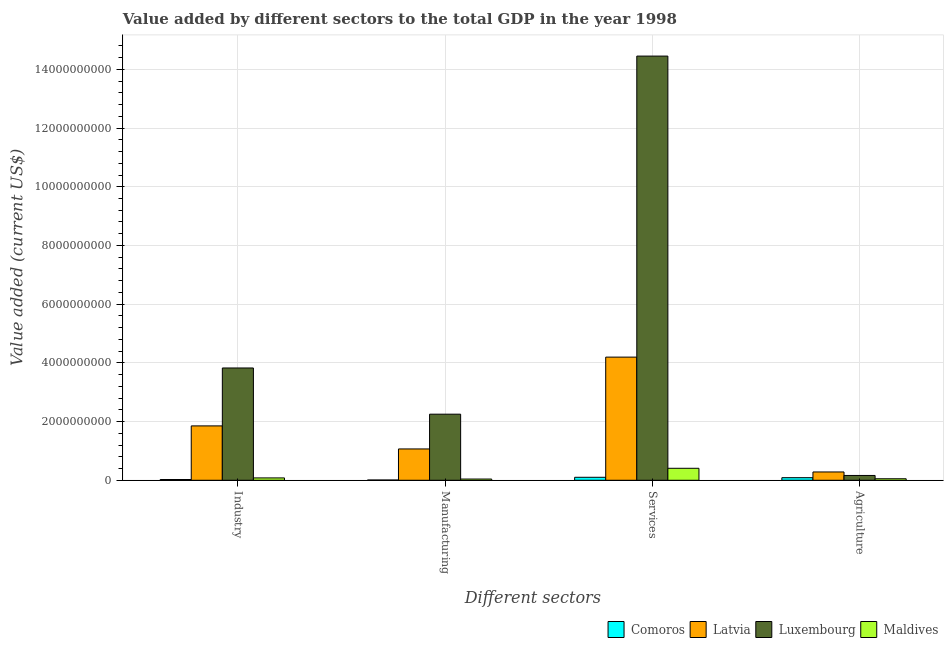Are the number of bars per tick equal to the number of legend labels?
Give a very brief answer. Yes. Are the number of bars on each tick of the X-axis equal?
Keep it short and to the point. Yes. How many bars are there on the 3rd tick from the left?
Provide a short and direct response. 4. What is the label of the 2nd group of bars from the left?
Your answer should be compact. Manufacturing. What is the value added by manufacturing sector in Comoros?
Provide a succinct answer. 8.97e+06. Across all countries, what is the maximum value added by industrial sector?
Your response must be concise. 3.83e+09. Across all countries, what is the minimum value added by services sector?
Provide a succinct answer. 1.02e+08. In which country was the value added by manufacturing sector maximum?
Ensure brevity in your answer.  Luxembourg. In which country was the value added by manufacturing sector minimum?
Make the answer very short. Comoros. What is the total value added by manufacturing sector in the graph?
Give a very brief answer. 3.37e+09. What is the difference between the value added by industrial sector in Latvia and that in Maldives?
Your answer should be very brief. 1.77e+09. What is the difference between the value added by manufacturing sector in Latvia and the value added by agricultural sector in Comoros?
Provide a succinct answer. 9.79e+08. What is the average value added by services sector per country?
Provide a short and direct response. 4.79e+09. What is the difference between the value added by manufacturing sector and value added by industrial sector in Comoros?
Your answer should be compact. -1.68e+07. What is the ratio of the value added by agricultural sector in Latvia to that in Luxembourg?
Keep it short and to the point. 1.73. Is the value added by manufacturing sector in Latvia less than that in Comoros?
Offer a terse response. No. What is the difference between the highest and the second highest value added by services sector?
Your answer should be compact. 1.03e+1. What is the difference between the highest and the lowest value added by industrial sector?
Your response must be concise. 3.80e+09. Is the sum of the value added by services sector in Latvia and Luxembourg greater than the maximum value added by manufacturing sector across all countries?
Provide a succinct answer. Yes. What does the 4th bar from the left in Services represents?
Keep it short and to the point. Maldives. What does the 3rd bar from the right in Manufacturing represents?
Provide a succinct answer. Latvia. How many countries are there in the graph?
Your answer should be compact. 4. Does the graph contain grids?
Offer a very short reply. Yes. Where does the legend appear in the graph?
Your response must be concise. Bottom right. How many legend labels are there?
Your response must be concise. 4. What is the title of the graph?
Offer a terse response. Value added by different sectors to the total GDP in the year 1998. What is the label or title of the X-axis?
Provide a short and direct response. Different sectors. What is the label or title of the Y-axis?
Offer a very short reply. Value added (current US$). What is the Value added (current US$) of Comoros in Industry?
Provide a short and direct response. 2.57e+07. What is the Value added (current US$) of Latvia in Industry?
Your answer should be compact. 1.85e+09. What is the Value added (current US$) in Luxembourg in Industry?
Your answer should be very brief. 3.83e+09. What is the Value added (current US$) in Maldives in Industry?
Provide a succinct answer. 8.04e+07. What is the Value added (current US$) in Comoros in Manufacturing?
Keep it short and to the point. 8.97e+06. What is the Value added (current US$) of Latvia in Manufacturing?
Ensure brevity in your answer.  1.07e+09. What is the Value added (current US$) of Luxembourg in Manufacturing?
Provide a short and direct response. 2.25e+09. What is the Value added (current US$) of Maldives in Manufacturing?
Offer a very short reply. 4.16e+07. What is the Value added (current US$) of Comoros in Services?
Your answer should be very brief. 1.02e+08. What is the Value added (current US$) in Latvia in Services?
Ensure brevity in your answer.  4.20e+09. What is the Value added (current US$) in Luxembourg in Services?
Ensure brevity in your answer.  1.45e+1. What is the Value added (current US$) in Maldives in Services?
Give a very brief answer. 4.08e+08. What is the Value added (current US$) of Comoros in Agriculture?
Keep it short and to the point. 8.82e+07. What is the Value added (current US$) in Latvia in Agriculture?
Your answer should be very brief. 2.83e+08. What is the Value added (current US$) in Luxembourg in Agriculture?
Ensure brevity in your answer.  1.64e+08. What is the Value added (current US$) in Maldives in Agriculture?
Ensure brevity in your answer.  5.16e+07. Across all Different sectors, what is the maximum Value added (current US$) in Comoros?
Provide a succinct answer. 1.02e+08. Across all Different sectors, what is the maximum Value added (current US$) of Latvia?
Give a very brief answer. 4.20e+09. Across all Different sectors, what is the maximum Value added (current US$) of Luxembourg?
Offer a terse response. 1.45e+1. Across all Different sectors, what is the maximum Value added (current US$) of Maldives?
Your answer should be very brief. 4.08e+08. Across all Different sectors, what is the minimum Value added (current US$) of Comoros?
Offer a terse response. 8.97e+06. Across all Different sectors, what is the minimum Value added (current US$) of Latvia?
Offer a very short reply. 2.83e+08. Across all Different sectors, what is the minimum Value added (current US$) of Luxembourg?
Your response must be concise. 1.64e+08. Across all Different sectors, what is the minimum Value added (current US$) of Maldives?
Give a very brief answer. 4.16e+07. What is the total Value added (current US$) of Comoros in the graph?
Keep it short and to the point. 2.24e+08. What is the total Value added (current US$) of Latvia in the graph?
Your answer should be very brief. 7.40e+09. What is the total Value added (current US$) in Luxembourg in the graph?
Provide a short and direct response. 2.07e+1. What is the total Value added (current US$) in Maldives in the graph?
Provide a succinct answer. 5.82e+08. What is the difference between the Value added (current US$) of Comoros in Industry and that in Manufacturing?
Ensure brevity in your answer.  1.68e+07. What is the difference between the Value added (current US$) in Latvia in Industry and that in Manufacturing?
Give a very brief answer. 7.85e+08. What is the difference between the Value added (current US$) of Luxembourg in Industry and that in Manufacturing?
Offer a terse response. 1.57e+09. What is the difference between the Value added (current US$) of Maldives in Industry and that in Manufacturing?
Ensure brevity in your answer.  3.88e+07. What is the difference between the Value added (current US$) in Comoros in Industry and that in Services?
Offer a terse response. -7.58e+07. What is the difference between the Value added (current US$) of Latvia in Industry and that in Services?
Provide a short and direct response. -2.34e+09. What is the difference between the Value added (current US$) of Luxembourg in Industry and that in Services?
Provide a short and direct response. -1.06e+1. What is the difference between the Value added (current US$) of Maldives in Industry and that in Services?
Provide a succinct answer. -3.28e+08. What is the difference between the Value added (current US$) in Comoros in Industry and that in Agriculture?
Make the answer very short. -6.24e+07. What is the difference between the Value added (current US$) of Latvia in Industry and that in Agriculture?
Make the answer very short. 1.57e+09. What is the difference between the Value added (current US$) of Luxembourg in Industry and that in Agriculture?
Your answer should be compact. 3.66e+09. What is the difference between the Value added (current US$) of Maldives in Industry and that in Agriculture?
Provide a succinct answer. 2.88e+07. What is the difference between the Value added (current US$) of Comoros in Manufacturing and that in Services?
Ensure brevity in your answer.  -9.25e+07. What is the difference between the Value added (current US$) of Latvia in Manufacturing and that in Services?
Your response must be concise. -3.13e+09. What is the difference between the Value added (current US$) of Luxembourg in Manufacturing and that in Services?
Offer a very short reply. -1.22e+1. What is the difference between the Value added (current US$) of Maldives in Manufacturing and that in Services?
Keep it short and to the point. -3.67e+08. What is the difference between the Value added (current US$) of Comoros in Manufacturing and that in Agriculture?
Provide a short and direct response. -7.92e+07. What is the difference between the Value added (current US$) of Latvia in Manufacturing and that in Agriculture?
Offer a terse response. 7.84e+08. What is the difference between the Value added (current US$) in Luxembourg in Manufacturing and that in Agriculture?
Give a very brief answer. 2.09e+09. What is the difference between the Value added (current US$) in Maldives in Manufacturing and that in Agriculture?
Your answer should be compact. -9.94e+06. What is the difference between the Value added (current US$) in Comoros in Services and that in Agriculture?
Your answer should be compact. 1.34e+07. What is the difference between the Value added (current US$) in Latvia in Services and that in Agriculture?
Keep it short and to the point. 3.91e+09. What is the difference between the Value added (current US$) in Luxembourg in Services and that in Agriculture?
Your response must be concise. 1.43e+1. What is the difference between the Value added (current US$) in Maldives in Services and that in Agriculture?
Keep it short and to the point. 3.57e+08. What is the difference between the Value added (current US$) in Comoros in Industry and the Value added (current US$) in Latvia in Manufacturing?
Offer a terse response. -1.04e+09. What is the difference between the Value added (current US$) of Comoros in Industry and the Value added (current US$) of Luxembourg in Manufacturing?
Give a very brief answer. -2.23e+09. What is the difference between the Value added (current US$) in Comoros in Industry and the Value added (current US$) in Maldives in Manufacturing?
Your answer should be very brief. -1.59e+07. What is the difference between the Value added (current US$) in Latvia in Industry and the Value added (current US$) in Luxembourg in Manufacturing?
Provide a short and direct response. -3.99e+08. What is the difference between the Value added (current US$) of Latvia in Industry and the Value added (current US$) of Maldives in Manufacturing?
Give a very brief answer. 1.81e+09. What is the difference between the Value added (current US$) of Luxembourg in Industry and the Value added (current US$) of Maldives in Manufacturing?
Your response must be concise. 3.78e+09. What is the difference between the Value added (current US$) in Comoros in Industry and the Value added (current US$) in Latvia in Services?
Your answer should be very brief. -4.17e+09. What is the difference between the Value added (current US$) in Comoros in Industry and the Value added (current US$) in Luxembourg in Services?
Offer a terse response. -1.44e+1. What is the difference between the Value added (current US$) in Comoros in Industry and the Value added (current US$) in Maldives in Services?
Keep it short and to the point. -3.82e+08. What is the difference between the Value added (current US$) in Latvia in Industry and the Value added (current US$) in Luxembourg in Services?
Your response must be concise. -1.26e+1. What is the difference between the Value added (current US$) of Latvia in Industry and the Value added (current US$) of Maldives in Services?
Offer a very short reply. 1.44e+09. What is the difference between the Value added (current US$) of Luxembourg in Industry and the Value added (current US$) of Maldives in Services?
Offer a very short reply. 3.42e+09. What is the difference between the Value added (current US$) in Comoros in Industry and the Value added (current US$) in Latvia in Agriculture?
Provide a succinct answer. -2.57e+08. What is the difference between the Value added (current US$) in Comoros in Industry and the Value added (current US$) in Luxembourg in Agriculture?
Give a very brief answer. -1.38e+08. What is the difference between the Value added (current US$) of Comoros in Industry and the Value added (current US$) of Maldives in Agriculture?
Ensure brevity in your answer.  -2.58e+07. What is the difference between the Value added (current US$) in Latvia in Industry and the Value added (current US$) in Luxembourg in Agriculture?
Your response must be concise. 1.69e+09. What is the difference between the Value added (current US$) in Latvia in Industry and the Value added (current US$) in Maldives in Agriculture?
Make the answer very short. 1.80e+09. What is the difference between the Value added (current US$) in Luxembourg in Industry and the Value added (current US$) in Maldives in Agriculture?
Offer a terse response. 3.77e+09. What is the difference between the Value added (current US$) in Comoros in Manufacturing and the Value added (current US$) in Latvia in Services?
Make the answer very short. -4.19e+09. What is the difference between the Value added (current US$) in Comoros in Manufacturing and the Value added (current US$) in Luxembourg in Services?
Your response must be concise. -1.44e+1. What is the difference between the Value added (current US$) in Comoros in Manufacturing and the Value added (current US$) in Maldives in Services?
Keep it short and to the point. -3.99e+08. What is the difference between the Value added (current US$) of Latvia in Manufacturing and the Value added (current US$) of Luxembourg in Services?
Offer a terse response. -1.34e+1. What is the difference between the Value added (current US$) in Latvia in Manufacturing and the Value added (current US$) in Maldives in Services?
Provide a succinct answer. 6.59e+08. What is the difference between the Value added (current US$) in Luxembourg in Manufacturing and the Value added (current US$) in Maldives in Services?
Give a very brief answer. 1.84e+09. What is the difference between the Value added (current US$) in Comoros in Manufacturing and the Value added (current US$) in Latvia in Agriculture?
Offer a terse response. -2.74e+08. What is the difference between the Value added (current US$) in Comoros in Manufacturing and the Value added (current US$) in Luxembourg in Agriculture?
Ensure brevity in your answer.  -1.55e+08. What is the difference between the Value added (current US$) of Comoros in Manufacturing and the Value added (current US$) of Maldives in Agriculture?
Make the answer very short. -4.26e+07. What is the difference between the Value added (current US$) in Latvia in Manufacturing and the Value added (current US$) in Luxembourg in Agriculture?
Your answer should be compact. 9.04e+08. What is the difference between the Value added (current US$) of Latvia in Manufacturing and the Value added (current US$) of Maldives in Agriculture?
Your response must be concise. 1.02e+09. What is the difference between the Value added (current US$) in Luxembourg in Manufacturing and the Value added (current US$) in Maldives in Agriculture?
Your answer should be very brief. 2.20e+09. What is the difference between the Value added (current US$) of Comoros in Services and the Value added (current US$) of Latvia in Agriculture?
Provide a short and direct response. -1.81e+08. What is the difference between the Value added (current US$) of Comoros in Services and the Value added (current US$) of Luxembourg in Agriculture?
Provide a succinct answer. -6.20e+07. What is the difference between the Value added (current US$) in Comoros in Services and the Value added (current US$) in Maldives in Agriculture?
Give a very brief answer. 4.99e+07. What is the difference between the Value added (current US$) in Latvia in Services and the Value added (current US$) in Luxembourg in Agriculture?
Offer a very short reply. 4.03e+09. What is the difference between the Value added (current US$) of Latvia in Services and the Value added (current US$) of Maldives in Agriculture?
Offer a terse response. 4.14e+09. What is the difference between the Value added (current US$) in Luxembourg in Services and the Value added (current US$) in Maldives in Agriculture?
Provide a succinct answer. 1.44e+1. What is the average Value added (current US$) in Comoros per Different sectors?
Your response must be concise. 5.61e+07. What is the average Value added (current US$) of Latvia per Different sectors?
Give a very brief answer. 1.85e+09. What is the average Value added (current US$) in Luxembourg per Different sectors?
Your response must be concise. 5.17e+09. What is the average Value added (current US$) of Maldives per Different sectors?
Provide a succinct answer. 1.45e+08. What is the difference between the Value added (current US$) of Comoros and Value added (current US$) of Latvia in Industry?
Provide a succinct answer. -1.83e+09. What is the difference between the Value added (current US$) of Comoros and Value added (current US$) of Luxembourg in Industry?
Make the answer very short. -3.80e+09. What is the difference between the Value added (current US$) in Comoros and Value added (current US$) in Maldives in Industry?
Give a very brief answer. -5.47e+07. What is the difference between the Value added (current US$) in Latvia and Value added (current US$) in Luxembourg in Industry?
Make the answer very short. -1.97e+09. What is the difference between the Value added (current US$) of Latvia and Value added (current US$) of Maldives in Industry?
Ensure brevity in your answer.  1.77e+09. What is the difference between the Value added (current US$) of Luxembourg and Value added (current US$) of Maldives in Industry?
Your answer should be compact. 3.75e+09. What is the difference between the Value added (current US$) in Comoros and Value added (current US$) in Latvia in Manufacturing?
Your response must be concise. -1.06e+09. What is the difference between the Value added (current US$) of Comoros and Value added (current US$) of Luxembourg in Manufacturing?
Give a very brief answer. -2.24e+09. What is the difference between the Value added (current US$) of Comoros and Value added (current US$) of Maldives in Manufacturing?
Provide a succinct answer. -3.27e+07. What is the difference between the Value added (current US$) in Latvia and Value added (current US$) in Luxembourg in Manufacturing?
Provide a short and direct response. -1.18e+09. What is the difference between the Value added (current US$) of Latvia and Value added (current US$) of Maldives in Manufacturing?
Provide a short and direct response. 1.03e+09. What is the difference between the Value added (current US$) in Luxembourg and Value added (current US$) in Maldives in Manufacturing?
Your answer should be very brief. 2.21e+09. What is the difference between the Value added (current US$) in Comoros and Value added (current US$) in Latvia in Services?
Make the answer very short. -4.09e+09. What is the difference between the Value added (current US$) of Comoros and Value added (current US$) of Luxembourg in Services?
Your answer should be very brief. -1.43e+1. What is the difference between the Value added (current US$) in Comoros and Value added (current US$) in Maldives in Services?
Keep it short and to the point. -3.07e+08. What is the difference between the Value added (current US$) in Latvia and Value added (current US$) in Luxembourg in Services?
Your response must be concise. -1.03e+1. What is the difference between the Value added (current US$) of Latvia and Value added (current US$) of Maldives in Services?
Your answer should be very brief. 3.79e+09. What is the difference between the Value added (current US$) of Luxembourg and Value added (current US$) of Maldives in Services?
Ensure brevity in your answer.  1.40e+1. What is the difference between the Value added (current US$) in Comoros and Value added (current US$) in Latvia in Agriculture?
Make the answer very short. -1.95e+08. What is the difference between the Value added (current US$) of Comoros and Value added (current US$) of Luxembourg in Agriculture?
Your answer should be very brief. -7.54e+07. What is the difference between the Value added (current US$) in Comoros and Value added (current US$) in Maldives in Agriculture?
Provide a short and direct response. 3.66e+07. What is the difference between the Value added (current US$) in Latvia and Value added (current US$) in Luxembourg in Agriculture?
Your answer should be very brief. 1.19e+08. What is the difference between the Value added (current US$) of Latvia and Value added (current US$) of Maldives in Agriculture?
Make the answer very short. 2.31e+08. What is the difference between the Value added (current US$) in Luxembourg and Value added (current US$) in Maldives in Agriculture?
Keep it short and to the point. 1.12e+08. What is the ratio of the Value added (current US$) of Comoros in Industry to that in Manufacturing?
Provide a succinct answer. 2.87. What is the ratio of the Value added (current US$) in Latvia in Industry to that in Manufacturing?
Your answer should be compact. 1.74. What is the ratio of the Value added (current US$) in Luxembourg in Industry to that in Manufacturing?
Your answer should be compact. 1.7. What is the ratio of the Value added (current US$) in Maldives in Industry to that in Manufacturing?
Offer a terse response. 1.93. What is the ratio of the Value added (current US$) in Comoros in Industry to that in Services?
Offer a very short reply. 0.25. What is the ratio of the Value added (current US$) of Latvia in Industry to that in Services?
Offer a very short reply. 0.44. What is the ratio of the Value added (current US$) in Luxembourg in Industry to that in Services?
Ensure brevity in your answer.  0.26. What is the ratio of the Value added (current US$) in Maldives in Industry to that in Services?
Keep it short and to the point. 0.2. What is the ratio of the Value added (current US$) in Comoros in Industry to that in Agriculture?
Provide a succinct answer. 0.29. What is the ratio of the Value added (current US$) in Latvia in Industry to that in Agriculture?
Offer a very short reply. 6.55. What is the ratio of the Value added (current US$) in Luxembourg in Industry to that in Agriculture?
Provide a succinct answer. 23.4. What is the ratio of the Value added (current US$) of Maldives in Industry to that in Agriculture?
Ensure brevity in your answer.  1.56. What is the ratio of the Value added (current US$) of Comoros in Manufacturing to that in Services?
Your answer should be very brief. 0.09. What is the ratio of the Value added (current US$) in Latvia in Manufacturing to that in Services?
Provide a succinct answer. 0.25. What is the ratio of the Value added (current US$) of Luxembourg in Manufacturing to that in Services?
Offer a terse response. 0.16. What is the ratio of the Value added (current US$) in Maldives in Manufacturing to that in Services?
Make the answer very short. 0.1. What is the ratio of the Value added (current US$) of Comoros in Manufacturing to that in Agriculture?
Your answer should be compact. 0.1. What is the ratio of the Value added (current US$) in Latvia in Manufacturing to that in Agriculture?
Keep it short and to the point. 3.77. What is the ratio of the Value added (current US$) in Luxembourg in Manufacturing to that in Agriculture?
Give a very brief answer. 13.77. What is the ratio of the Value added (current US$) in Maldives in Manufacturing to that in Agriculture?
Provide a short and direct response. 0.81. What is the ratio of the Value added (current US$) in Comoros in Services to that in Agriculture?
Your answer should be compact. 1.15. What is the ratio of the Value added (current US$) in Latvia in Services to that in Agriculture?
Give a very brief answer. 14.84. What is the ratio of the Value added (current US$) of Luxembourg in Services to that in Agriculture?
Provide a succinct answer. 88.38. What is the ratio of the Value added (current US$) of Maldives in Services to that in Agriculture?
Your response must be concise. 7.91. What is the difference between the highest and the second highest Value added (current US$) of Comoros?
Keep it short and to the point. 1.34e+07. What is the difference between the highest and the second highest Value added (current US$) of Latvia?
Your response must be concise. 2.34e+09. What is the difference between the highest and the second highest Value added (current US$) in Luxembourg?
Make the answer very short. 1.06e+1. What is the difference between the highest and the second highest Value added (current US$) in Maldives?
Keep it short and to the point. 3.28e+08. What is the difference between the highest and the lowest Value added (current US$) of Comoros?
Keep it short and to the point. 9.25e+07. What is the difference between the highest and the lowest Value added (current US$) in Latvia?
Give a very brief answer. 3.91e+09. What is the difference between the highest and the lowest Value added (current US$) of Luxembourg?
Give a very brief answer. 1.43e+1. What is the difference between the highest and the lowest Value added (current US$) of Maldives?
Provide a short and direct response. 3.67e+08. 